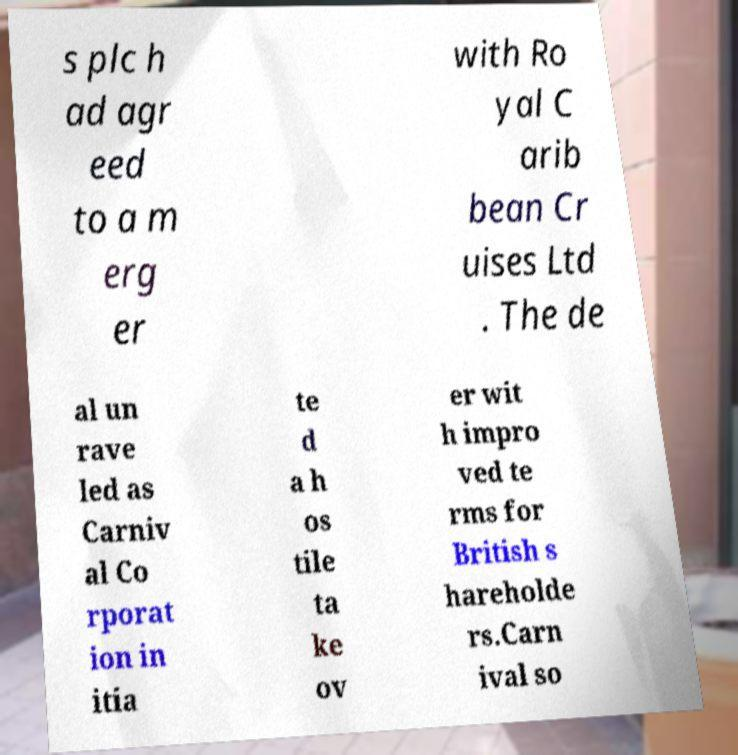Please identify and transcribe the text found in this image. s plc h ad agr eed to a m erg er with Ro yal C arib bean Cr uises Ltd . The de al un rave led as Carniv al Co rporat ion in itia te d a h os tile ta ke ov er wit h impro ved te rms for British s hareholde rs.Carn ival so 